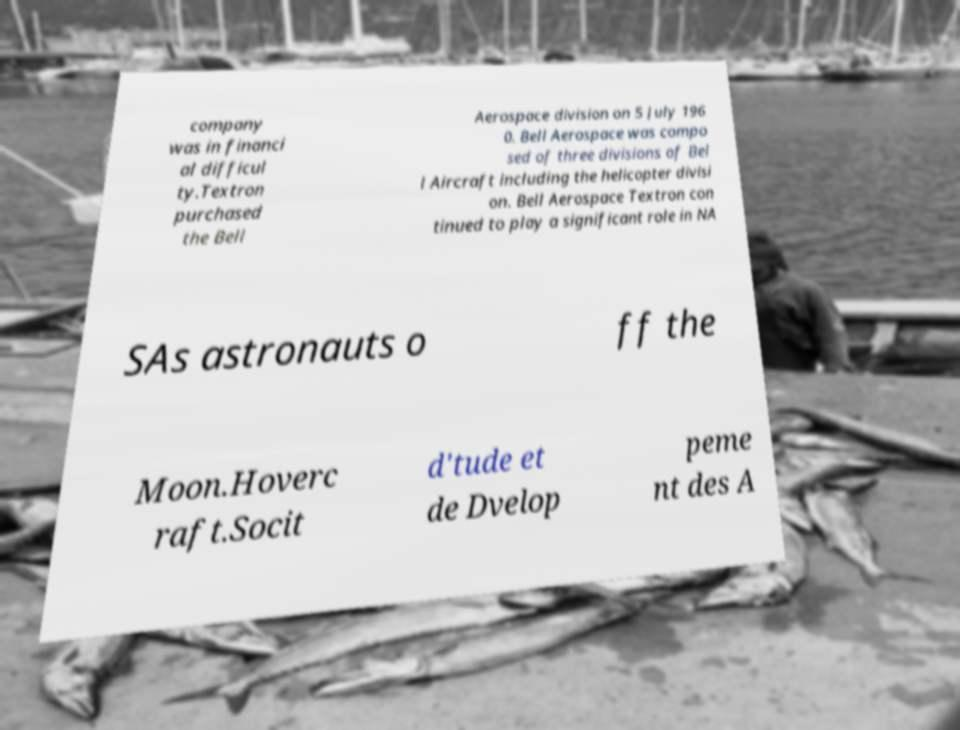I need the written content from this picture converted into text. Can you do that? company was in financi al difficul ty.Textron purchased the Bell Aerospace division on 5 July 196 0. Bell Aerospace was compo sed of three divisions of Bel l Aircraft including the helicopter divisi on. Bell Aerospace Textron con tinued to play a significant role in NA SAs astronauts o ff the Moon.Hoverc raft.Socit d'tude et de Dvelop peme nt des A 